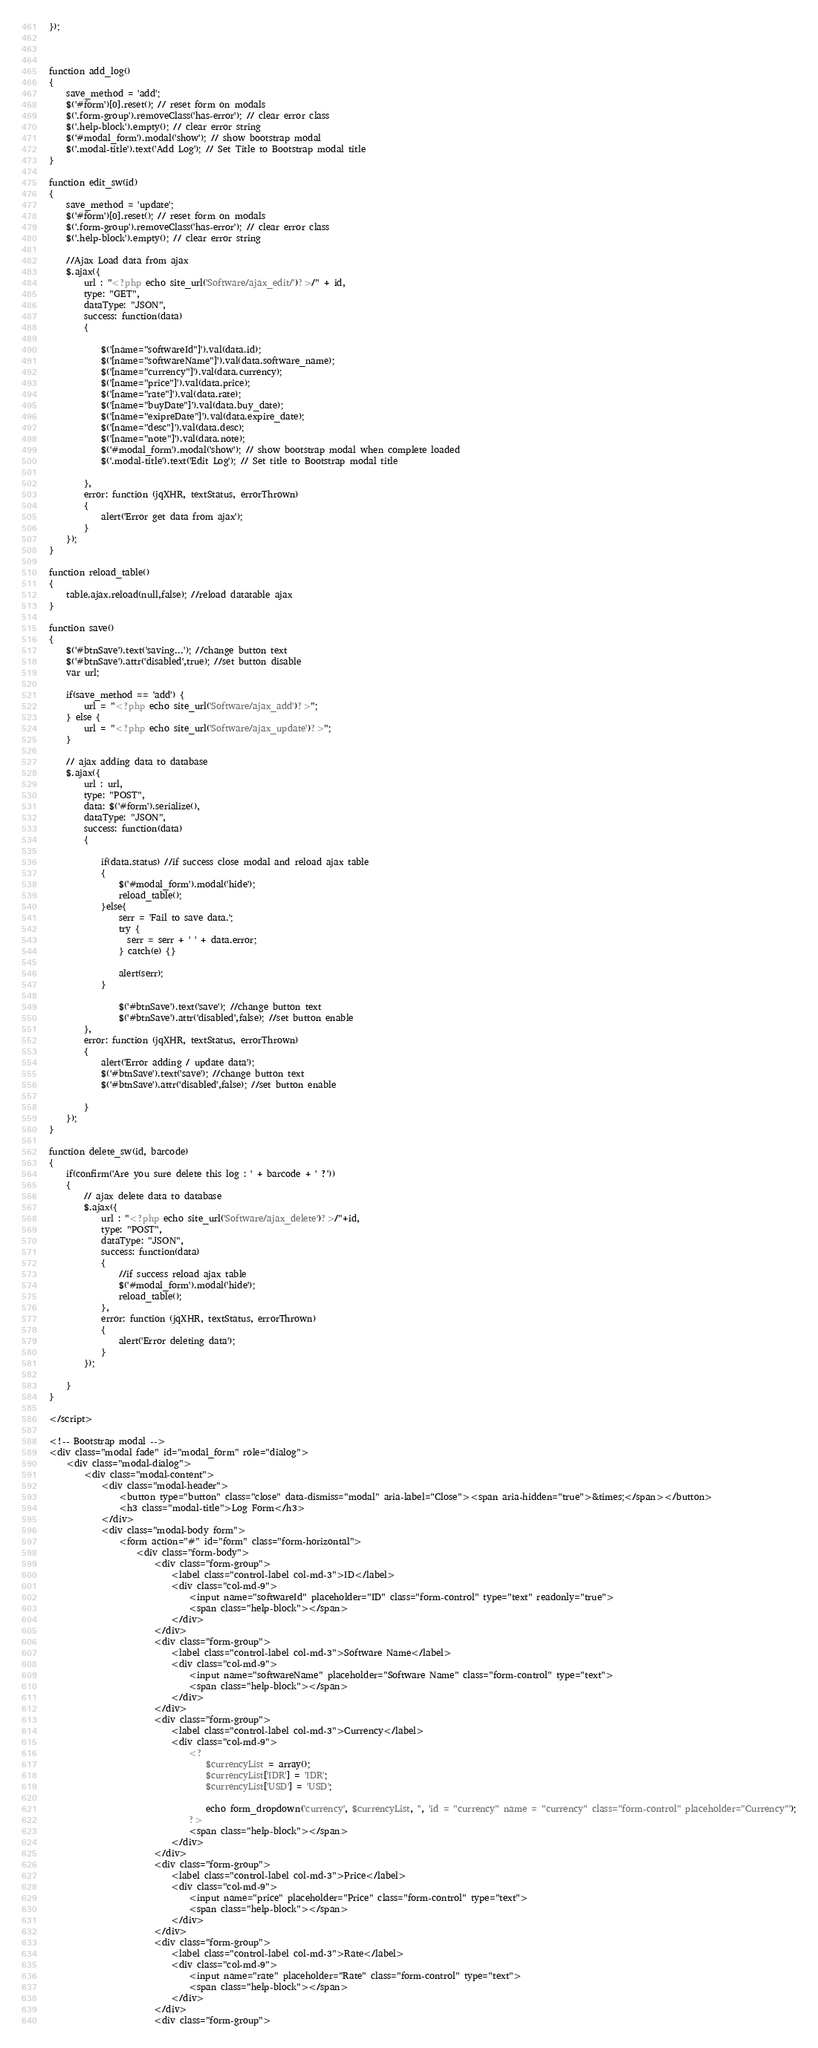<code> <loc_0><loc_0><loc_500><loc_500><_PHP_>
});



function add_log()
{
    save_method = 'add';
    $('#form')[0].reset(); // reset form on modals
    $('.form-group').removeClass('has-error'); // clear error class
    $('.help-block').empty(); // clear error string
    $('#modal_form').modal('show'); // show bootstrap modal
    $('.modal-title').text('Add Log'); // Set Title to Bootstrap modal title
}

function edit_sw(id)
{
    save_method = 'update';
    $('#form')[0].reset(); // reset form on modals
    $('.form-group').removeClass('has-error'); // clear error class
    $('.help-block').empty(); // clear error string

    //Ajax Load data from ajax
    $.ajax({
        url : "<?php echo site_url('Software/ajax_edit/')?>/" + id,
        type: "GET",
        dataType: "JSON",
        success: function(data)
        {

            $('[name="softwareId"]').val(data.id);
            $('[name="softwareName"]').val(data.software_name);
            $('[name="currency"]').val(data.currency);
            $('[name="price"]').val(data.price);
            $('[name="rate"]').val(data.rate);
            $('[name="buyDate"]').val(data.buy_date);
            $('[name="exipreDate"]').val(data.expire_date);
            $('[name="desc"]').val(data.desc);
            $('[name="note"]').val(data.note);
            $('#modal_form').modal('show'); // show bootstrap modal when complete loaded
            $('.modal-title').text('Edit Log'); // Set title to Bootstrap modal title

        },
        error: function (jqXHR, textStatus, errorThrown)
        {
            alert('Error get data from ajax');
        }
    });
}

function reload_table()
{
    table.ajax.reload(null,false); //reload datatable ajax 
}

function save()
{
    $('#btnSave').text('saving...'); //change button text
    $('#btnSave').attr('disabled',true); //set button disable 
    var url;

    if(save_method == 'add') {
        url = "<?php echo site_url('Software/ajax_add')?>";
    } else {
        url = "<?php echo site_url('Software/ajax_update')?>";
    }

    // ajax adding data to database
    $.ajax({
        url : url,
        type: "POST",
        data: $('#form').serialize(),
        dataType: "JSON",
        success: function(data)
        {

            if(data.status) //if success close modal and reload ajax table
            {
                $('#modal_form').modal('hide');
                reload_table();
            }else{
                serr = 'Fail to save data.';
                try {
                  serr = serr + ' ' + data.error;
                } catch(e) {}
                
                alert(serr);
            }

                $('#btnSave').text('save'); //change button text
                $('#btnSave').attr('disabled',false); //set button enable 
        },
        error: function (jqXHR, textStatus, errorThrown)
        {
            alert('Error adding / update data');
            $('#btnSave').text('save'); //change button text
            $('#btnSave').attr('disabled',false); //set button enable 

        }
    });
}

function delete_sw(id, barcode)
{
    if(confirm('Are you sure delete this log : ' + barcode + ' ?'))
    {
        // ajax delete data to database
        $.ajax({
            url : "<?php echo site_url('Software/ajax_delete')?>/"+id,
            type: "POST",
            dataType: "JSON",
            success: function(data)
            {
                //if success reload ajax table
                $('#modal_form').modal('hide');
                reload_table();
            },
            error: function (jqXHR, textStatus, errorThrown)
            {
                alert('Error deleting data');
            }
        });

    }
}

</script>

<!-- Bootstrap modal -->
<div class="modal fade" id="modal_form" role="dialog">
    <div class="modal-dialog">
        <div class="modal-content">
            <div class="modal-header">
                <button type="button" class="close" data-dismiss="modal" aria-label="Close"><span aria-hidden="true">&times;</span></button>
                <h3 class="modal-title">Log Form</h3>
            </div>
            <div class="modal-body form">
                <form action="#" id="form" class="form-horizontal">
                    <div class="form-body">
                        <div class="form-group">
                            <label class="control-label col-md-3">ID</label>
                            <div class="col-md-9">
                                <input name="softwareId" placeholder="ID" class="form-control" type="text" readonly="true">
                                <span class="help-block"></span>
                            </div>
                        </div>
                        <div class="form-group">
                            <label class="control-label col-md-3">Software Name</label>
                            <div class="col-md-9">
                                <input name="softwareName" placeholder="Software Name" class="form-control" type="text">
                                <span class="help-block"></span>
                            </div>
                        </div>
                        <div class="form-group">
                            <label class="control-label col-md-3">Currency</label>
                            <div class="col-md-9">
                                <?
                                    $currencyList = array();
                                    $currencyList['IDR'] = 'IDR';
                                    $currencyList['USD'] = 'USD';

                                    echo form_dropdown('currency', $currencyList, '', 'id = "currency" name = "currency" class="form-control" placeholder="Currency"');
                                ?>
                                <span class="help-block"></span>
                            </div>
                        </div>
                        <div class="form-group">
                            <label class="control-label col-md-3">Price</label>
                            <div class="col-md-9">
                                <input name="price" placeholder="Price" class="form-control" type="text">
                                <span class="help-block"></span>
                            </div>
                        </div>
                        <div class="form-group">
                            <label class="control-label col-md-3">Rate</label>
                            <div class="col-md-9">
                                <input name="rate" placeholder="Rate" class="form-control" type="text">
                                <span class="help-block"></span>
                            </div>
                        </div>
                        <div class="form-group"></code> 